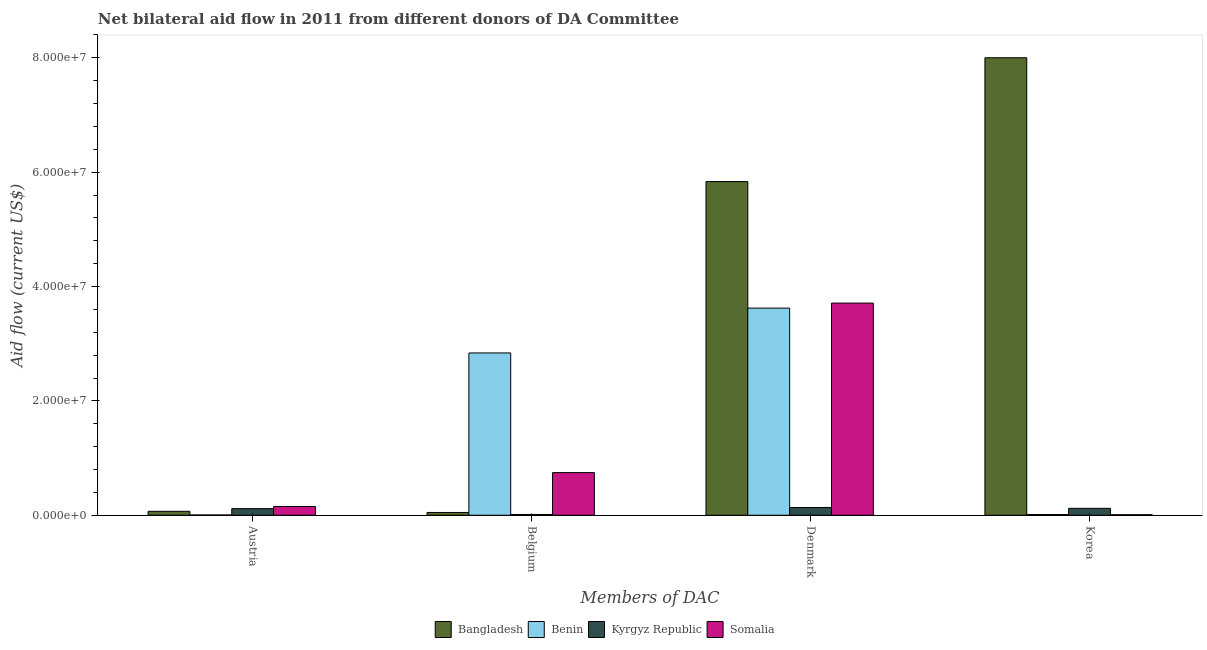How many different coloured bars are there?
Offer a very short reply. 4. How many groups of bars are there?
Ensure brevity in your answer.  4. Are the number of bars per tick equal to the number of legend labels?
Offer a very short reply. Yes. Are the number of bars on each tick of the X-axis equal?
Your answer should be compact. Yes. How many bars are there on the 1st tick from the left?
Your answer should be very brief. 4. How many bars are there on the 4th tick from the right?
Your answer should be very brief. 4. What is the label of the 2nd group of bars from the left?
Keep it short and to the point. Belgium. What is the amount of aid given by austria in Kyrgyz Republic?
Make the answer very short. 1.16e+06. Across all countries, what is the maximum amount of aid given by austria?
Keep it short and to the point. 1.54e+06. Across all countries, what is the minimum amount of aid given by austria?
Keep it short and to the point. 5.00e+04. In which country was the amount of aid given by belgium maximum?
Your answer should be very brief. Benin. In which country was the amount of aid given by belgium minimum?
Keep it short and to the point. Kyrgyz Republic. What is the total amount of aid given by belgium in the graph?
Make the answer very short. 3.65e+07. What is the difference between the amount of aid given by austria in Bangladesh and that in Benin?
Ensure brevity in your answer.  6.40e+05. What is the difference between the amount of aid given by belgium in Bangladesh and the amount of aid given by austria in Kyrgyz Republic?
Your response must be concise. -6.70e+05. What is the average amount of aid given by austria per country?
Your response must be concise. 8.60e+05. What is the difference between the amount of aid given by belgium and amount of aid given by denmark in Bangladesh?
Provide a short and direct response. -5.79e+07. In how many countries, is the amount of aid given by austria greater than 16000000 US$?
Your response must be concise. 0. What is the ratio of the amount of aid given by austria in Bangladesh to that in Kyrgyz Republic?
Offer a terse response. 0.59. Is the amount of aid given by belgium in Kyrgyz Republic less than that in Somalia?
Offer a very short reply. Yes. Is the difference between the amount of aid given by korea in Somalia and Bangladesh greater than the difference between the amount of aid given by belgium in Somalia and Bangladesh?
Ensure brevity in your answer.  No. What is the difference between the highest and the second highest amount of aid given by austria?
Ensure brevity in your answer.  3.80e+05. What is the difference between the highest and the lowest amount of aid given by denmark?
Make the answer very short. 5.70e+07. In how many countries, is the amount of aid given by austria greater than the average amount of aid given by austria taken over all countries?
Your answer should be compact. 2. Is the sum of the amount of aid given by belgium in Somalia and Benin greater than the maximum amount of aid given by austria across all countries?
Give a very brief answer. Yes. What does the 4th bar from the left in Denmark represents?
Your response must be concise. Somalia. What does the 3rd bar from the right in Korea represents?
Give a very brief answer. Benin. Is it the case that in every country, the sum of the amount of aid given by austria and amount of aid given by belgium is greater than the amount of aid given by denmark?
Your response must be concise. No. How many bars are there?
Your response must be concise. 16. Are all the bars in the graph horizontal?
Provide a short and direct response. No. What is the difference between two consecutive major ticks on the Y-axis?
Your answer should be very brief. 2.00e+07. How many legend labels are there?
Give a very brief answer. 4. What is the title of the graph?
Your answer should be compact. Net bilateral aid flow in 2011 from different donors of DA Committee. Does "Caribbean small states" appear as one of the legend labels in the graph?
Give a very brief answer. No. What is the label or title of the X-axis?
Offer a terse response. Members of DAC. What is the label or title of the Y-axis?
Make the answer very short. Aid flow (current US$). What is the Aid flow (current US$) in Bangladesh in Austria?
Ensure brevity in your answer.  6.90e+05. What is the Aid flow (current US$) in Kyrgyz Republic in Austria?
Ensure brevity in your answer.  1.16e+06. What is the Aid flow (current US$) in Somalia in Austria?
Your answer should be very brief. 1.54e+06. What is the Aid flow (current US$) in Benin in Belgium?
Offer a terse response. 2.84e+07. What is the Aid flow (current US$) in Somalia in Belgium?
Offer a very short reply. 7.46e+06. What is the Aid flow (current US$) in Bangladesh in Denmark?
Keep it short and to the point. 5.84e+07. What is the Aid flow (current US$) of Benin in Denmark?
Keep it short and to the point. 3.62e+07. What is the Aid flow (current US$) in Kyrgyz Republic in Denmark?
Your answer should be compact. 1.36e+06. What is the Aid flow (current US$) of Somalia in Denmark?
Make the answer very short. 3.71e+07. What is the Aid flow (current US$) in Bangladesh in Korea?
Offer a very short reply. 8.00e+07. What is the Aid flow (current US$) in Kyrgyz Republic in Korea?
Your response must be concise. 1.21e+06. Across all Members of DAC, what is the maximum Aid flow (current US$) in Bangladesh?
Your response must be concise. 8.00e+07. Across all Members of DAC, what is the maximum Aid flow (current US$) of Benin?
Your response must be concise. 3.62e+07. Across all Members of DAC, what is the maximum Aid flow (current US$) in Kyrgyz Republic?
Your answer should be very brief. 1.36e+06. Across all Members of DAC, what is the maximum Aid flow (current US$) of Somalia?
Offer a terse response. 3.71e+07. Across all Members of DAC, what is the minimum Aid flow (current US$) in Bangladesh?
Your answer should be compact. 4.90e+05. Across all Members of DAC, what is the minimum Aid flow (current US$) of Benin?
Ensure brevity in your answer.  5.00e+04. What is the total Aid flow (current US$) in Bangladesh in the graph?
Make the answer very short. 1.40e+08. What is the total Aid flow (current US$) of Benin in the graph?
Your answer should be very brief. 6.48e+07. What is the total Aid flow (current US$) of Kyrgyz Republic in the graph?
Provide a succinct answer. 3.87e+06. What is the total Aid flow (current US$) of Somalia in the graph?
Keep it short and to the point. 4.62e+07. What is the difference between the Aid flow (current US$) in Benin in Austria and that in Belgium?
Offer a very short reply. -2.83e+07. What is the difference between the Aid flow (current US$) in Kyrgyz Republic in Austria and that in Belgium?
Provide a short and direct response. 1.02e+06. What is the difference between the Aid flow (current US$) in Somalia in Austria and that in Belgium?
Your answer should be very brief. -5.92e+06. What is the difference between the Aid flow (current US$) in Bangladesh in Austria and that in Denmark?
Your response must be concise. -5.77e+07. What is the difference between the Aid flow (current US$) in Benin in Austria and that in Denmark?
Your answer should be very brief. -3.62e+07. What is the difference between the Aid flow (current US$) of Somalia in Austria and that in Denmark?
Offer a very short reply. -3.56e+07. What is the difference between the Aid flow (current US$) of Bangladesh in Austria and that in Korea?
Offer a very short reply. -7.93e+07. What is the difference between the Aid flow (current US$) in Kyrgyz Republic in Austria and that in Korea?
Offer a terse response. -5.00e+04. What is the difference between the Aid flow (current US$) of Somalia in Austria and that in Korea?
Keep it short and to the point. 1.44e+06. What is the difference between the Aid flow (current US$) of Bangladesh in Belgium and that in Denmark?
Your response must be concise. -5.79e+07. What is the difference between the Aid flow (current US$) of Benin in Belgium and that in Denmark?
Your answer should be very brief. -7.84e+06. What is the difference between the Aid flow (current US$) of Kyrgyz Republic in Belgium and that in Denmark?
Provide a short and direct response. -1.22e+06. What is the difference between the Aid flow (current US$) in Somalia in Belgium and that in Denmark?
Your answer should be compact. -2.96e+07. What is the difference between the Aid flow (current US$) in Bangladesh in Belgium and that in Korea?
Provide a short and direct response. -7.95e+07. What is the difference between the Aid flow (current US$) in Benin in Belgium and that in Korea?
Offer a terse response. 2.83e+07. What is the difference between the Aid flow (current US$) in Kyrgyz Republic in Belgium and that in Korea?
Your response must be concise. -1.07e+06. What is the difference between the Aid flow (current US$) of Somalia in Belgium and that in Korea?
Ensure brevity in your answer.  7.36e+06. What is the difference between the Aid flow (current US$) in Bangladesh in Denmark and that in Korea?
Offer a terse response. -2.17e+07. What is the difference between the Aid flow (current US$) in Benin in Denmark and that in Korea?
Ensure brevity in your answer.  3.61e+07. What is the difference between the Aid flow (current US$) in Kyrgyz Republic in Denmark and that in Korea?
Your answer should be compact. 1.50e+05. What is the difference between the Aid flow (current US$) in Somalia in Denmark and that in Korea?
Provide a short and direct response. 3.70e+07. What is the difference between the Aid flow (current US$) in Bangladesh in Austria and the Aid flow (current US$) in Benin in Belgium?
Your answer should be very brief. -2.77e+07. What is the difference between the Aid flow (current US$) in Bangladesh in Austria and the Aid flow (current US$) in Somalia in Belgium?
Your answer should be very brief. -6.77e+06. What is the difference between the Aid flow (current US$) of Benin in Austria and the Aid flow (current US$) of Kyrgyz Republic in Belgium?
Your answer should be very brief. -9.00e+04. What is the difference between the Aid flow (current US$) of Benin in Austria and the Aid flow (current US$) of Somalia in Belgium?
Keep it short and to the point. -7.41e+06. What is the difference between the Aid flow (current US$) of Kyrgyz Republic in Austria and the Aid flow (current US$) of Somalia in Belgium?
Keep it short and to the point. -6.30e+06. What is the difference between the Aid flow (current US$) of Bangladesh in Austria and the Aid flow (current US$) of Benin in Denmark?
Your answer should be very brief. -3.55e+07. What is the difference between the Aid flow (current US$) of Bangladesh in Austria and the Aid flow (current US$) of Kyrgyz Republic in Denmark?
Make the answer very short. -6.70e+05. What is the difference between the Aid flow (current US$) in Bangladesh in Austria and the Aid flow (current US$) in Somalia in Denmark?
Keep it short and to the point. -3.64e+07. What is the difference between the Aid flow (current US$) in Benin in Austria and the Aid flow (current US$) in Kyrgyz Republic in Denmark?
Provide a short and direct response. -1.31e+06. What is the difference between the Aid flow (current US$) of Benin in Austria and the Aid flow (current US$) of Somalia in Denmark?
Offer a terse response. -3.71e+07. What is the difference between the Aid flow (current US$) of Kyrgyz Republic in Austria and the Aid flow (current US$) of Somalia in Denmark?
Your response must be concise. -3.60e+07. What is the difference between the Aid flow (current US$) in Bangladesh in Austria and the Aid flow (current US$) in Benin in Korea?
Provide a succinct answer. 5.60e+05. What is the difference between the Aid flow (current US$) of Bangladesh in Austria and the Aid flow (current US$) of Kyrgyz Republic in Korea?
Provide a succinct answer. -5.20e+05. What is the difference between the Aid flow (current US$) of Bangladesh in Austria and the Aid flow (current US$) of Somalia in Korea?
Ensure brevity in your answer.  5.90e+05. What is the difference between the Aid flow (current US$) of Benin in Austria and the Aid flow (current US$) of Kyrgyz Republic in Korea?
Offer a terse response. -1.16e+06. What is the difference between the Aid flow (current US$) of Kyrgyz Republic in Austria and the Aid flow (current US$) of Somalia in Korea?
Provide a succinct answer. 1.06e+06. What is the difference between the Aid flow (current US$) of Bangladesh in Belgium and the Aid flow (current US$) of Benin in Denmark?
Offer a very short reply. -3.57e+07. What is the difference between the Aid flow (current US$) of Bangladesh in Belgium and the Aid flow (current US$) of Kyrgyz Republic in Denmark?
Keep it short and to the point. -8.70e+05. What is the difference between the Aid flow (current US$) of Bangladesh in Belgium and the Aid flow (current US$) of Somalia in Denmark?
Your answer should be compact. -3.66e+07. What is the difference between the Aid flow (current US$) in Benin in Belgium and the Aid flow (current US$) in Kyrgyz Republic in Denmark?
Ensure brevity in your answer.  2.70e+07. What is the difference between the Aid flow (current US$) in Benin in Belgium and the Aid flow (current US$) in Somalia in Denmark?
Keep it short and to the point. -8.72e+06. What is the difference between the Aid flow (current US$) in Kyrgyz Republic in Belgium and the Aid flow (current US$) in Somalia in Denmark?
Provide a succinct answer. -3.70e+07. What is the difference between the Aid flow (current US$) in Bangladesh in Belgium and the Aid flow (current US$) in Kyrgyz Republic in Korea?
Offer a very short reply. -7.20e+05. What is the difference between the Aid flow (current US$) of Bangladesh in Belgium and the Aid flow (current US$) of Somalia in Korea?
Provide a short and direct response. 3.90e+05. What is the difference between the Aid flow (current US$) of Benin in Belgium and the Aid flow (current US$) of Kyrgyz Republic in Korea?
Offer a terse response. 2.72e+07. What is the difference between the Aid flow (current US$) of Benin in Belgium and the Aid flow (current US$) of Somalia in Korea?
Your answer should be very brief. 2.83e+07. What is the difference between the Aid flow (current US$) of Kyrgyz Republic in Belgium and the Aid flow (current US$) of Somalia in Korea?
Provide a short and direct response. 4.00e+04. What is the difference between the Aid flow (current US$) of Bangladesh in Denmark and the Aid flow (current US$) of Benin in Korea?
Your answer should be compact. 5.82e+07. What is the difference between the Aid flow (current US$) in Bangladesh in Denmark and the Aid flow (current US$) in Kyrgyz Republic in Korea?
Your answer should be compact. 5.72e+07. What is the difference between the Aid flow (current US$) in Bangladesh in Denmark and the Aid flow (current US$) in Somalia in Korea?
Your answer should be compact. 5.83e+07. What is the difference between the Aid flow (current US$) in Benin in Denmark and the Aid flow (current US$) in Kyrgyz Republic in Korea?
Keep it short and to the point. 3.50e+07. What is the difference between the Aid flow (current US$) in Benin in Denmark and the Aid flow (current US$) in Somalia in Korea?
Provide a short and direct response. 3.61e+07. What is the difference between the Aid flow (current US$) of Kyrgyz Republic in Denmark and the Aid flow (current US$) of Somalia in Korea?
Give a very brief answer. 1.26e+06. What is the average Aid flow (current US$) in Bangladesh per Members of DAC?
Provide a short and direct response. 3.49e+07. What is the average Aid flow (current US$) of Benin per Members of DAC?
Your answer should be very brief. 1.62e+07. What is the average Aid flow (current US$) of Kyrgyz Republic per Members of DAC?
Give a very brief answer. 9.68e+05. What is the average Aid flow (current US$) in Somalia per Members of DAC?
Make the answer very short. 1.16e+07. What is the difference between the Aid flow (current US$) of Bangladesh and Aid flow (current US$) of Benin in Austria?
Ensure brevity in your answer.  6.40e+05. What is the difference between the Aid flow (current US$) in Bangladesh and Aid flow (current US$) in Kyrgyz Republic in Austria?
Provide a succinct answer. -4.70e+05. What is the difference between the Aid flow (current US$) in Bangladesh and Aid flow (current US$) in Somalia in Austria?
Your response must be concise. -8.50e+05. What is the difference between the Aid flow (current US$) of Benin and Aid flow (current US$) of Kyrgyz Republic in Austria?
Provide a short and direct response. -1.11e+06. What is the difference between the Aid flow (current US$) in Benin and Aid flow (current US$) in Somalia in Austria?
Provide a succinct answer. -1.49e+06. What is the difference between the Aid flow (current US$) of Kyrgyz Republic and Aid flow (current US$) of Somalia in Austria?
Your response must be concise. -3.80e+05. What is the difference between the Aid flow (current US$) in Bangladesh and Aid flow (current US$) in Benin in Belgium?
Your answer should be very brief. -2.79e+07. What is the difference between the Aid flow (current US$) in Bangladesh and Aid flow (current US$) in Kyrgyz Republic in Belgium?
Your response must be concise. 3.50e+05. What is the difference between the Aid flow (current US$) in Bangladesh and Aid flow (current US$) in Somalia in Belgium?
Offer a terse response. -6.97e+06. What is the difference between the Aid flow (current US$) in Benin and Aid flow (current US$) in Kyrgyz Republic in Belgium?
Provide a short and direct response. 2.82e+07. What is the difference between the Aid flow (current US$) in Benin and Aid flow (current US$) in Somalia in Belgium?
Your answer should be very brief. 2.09e+07. What is the difference between the Aid flow (current US$) in Kyrgyz Republic and Aid flow (current US$) in Somalia in Belgium?
Your response must be concise. -7.32e+06. What is the difference between the Aid flow (current US$) of Bangladesh and Aid flow (current US$) of Benin in Denmark?
Ensure brevity in your answer.  2.21e+07. What is the difference between the Aid flow (current US$) of Bangladesh and Aid flow (current US$) of Kyrgyz Republic in Denmark?
Your answer should be compact. 5.70e+07. What is the difference between the Aid flow (current US$) of Bangladesh and Aid flow (current US$) of Somalia in Denmark?
Keep it short and to the point. 2.12e+07. What is the difference between the Aid flow (current US$) in Benin and Aid flow (current US$) in Kyrgyz Republic in Denmark?
Offer a terse response. 3.49e+07. What is the difference between the Aid flow (current US$) of Benin and Aid flow (current US$) of Somalia in Denmark?
Your response must be concise. -8.80e+05. What is the difference between the Aid flow (current US$) of Kyrgyz Republic and Aid flow (current US$) of Somalia in Denmark?
Offer a very short reply. -3.58e+07. What is the difference between the Aid flow (current US$) of Bangladesh and Aid flow (current US$) of Benin in Korea?
Your response must be concise. 7.99e+07. What is the difference between the Aid flow (current US$) in Bangladesh and Aid flow (current US$) in Kyrgyz Republic in Korea?
Keep it short and to the point. 7.88e+07. What is the difference between the Aid flow (current US$) in Bangladesh and Aid flow (current US$) in Somalia in Korea?
Provide a succinct answer. 7.99e+07. What is the difference between the Aid flow (current US$) in Benin and Aid flow (current US$) in Kyrgyz Republic in Korea?
Provide a short and direct response. -1.08e+06. What is the difference between the Aid flow (current US$) in Kyrgyz Republic and Aid flow (current US$) in Somalia in Korea?
Ensure brevity in your answer.  1.11e+06. What is the ratio of the Aid flow (current US$) of Bangladesh in Austria to that in Belgium?
Provide a short and direct response. 1.41. What is the ratio of the Aid flow (current US$) in Benin in Austria to that in Belgium?
Offer a very short reply. 0. What is the ratio of the Aid flow (current US$) in Kyrgyz Republic in Austria to that in Belgium?
Offer a very short reply. 8.29. What is the ratio of the Aid flow (current US$) of Somalia in Austria to that in Belgium?
Give a very brief answer. 0.21. What is the ratio of the Aid flow (current US$) in Bangladesh in Austria to that in Denmark?
Provide a short and direct response. 0.01. What is the ratio of the Aid flow (current US$) in Benin in Austria to that in Denmark?
Offer a very short reply. 0. What is the ratio of the Aid flow (current US$) in Kyrgyz Republic in Austria to that in Denmark?
Your response must be concise. 0.85. What is the ratio of the Aid flow (current US$) in Somalia in Austria to that in Denmark?
Provide a short and direct response. 0.04. What is the ratio of the Aid flow (current US$) of Bangladesh in Austria to that in Korea?
Ensure brevity in your answer.  0.01. What is the ratio of the Aid flow (current US$) in Benin in Austria to that in Korea?
Make the answer very short. 0.38. What is the ratio of the Aid flow (current US$) in Kyrgyz Republic in Austria to that in Korea?
Keep it short and to the point. 0.96. What is the ratio of the Aid flow (current US$) of Somalia in Austria to that in Korea?
Your answer should be compact. 15.4. What is the ratio of the Aid flow (current US$) of Bangladesh in Belgium to that in Denmark?
Your answer should be compact. 0.01. What is the ratio of the Aid flow (current US$) of Benin in Belgium to that in Denmark?
Give a very brief answer. 0.78. What is the ratio of the Aid flow (current US$) in Kyrgyz Republic in Belgium to that in Denmark?
Your response must be concise. 0.1. What is the ratio of the Aid flow (current US$) in Somalia in Belgium to that in Denmark?
Provide a short and direct response. 0.2. What is the ratio of the Aid flow (current US$) in Bangladesh in Belgium to that in Korea?
Give a very brief answer. 0.01. What is the ratio of the Aid flow (current US$) in Benin in Belgium to that in Korea?
Provide a short and direct response. 218.38. What is the ratio of the Aid flow (current US$) of Kyrgyz Republic in Belgium to that in Korea?
Make the answer very short. 0.12. What is the ratio of the Aid flow (current US$) of Somalia in Belgium to that in Korea?
Give a very brief answer. 74.6. What is the ratio of the Aid flow (current US$) of Bangladesh in Denmark to that in Korea?
Offer a very short reply. 0.73. What is the ratio of the Aid flow (current US$) of Benin in Denmark to that in Korea?
Your answer should be very brief. 278.69. What is the ratio of the Aid flow (current US$) in Kyrgyz Republic in Denmark to that in Korea?
Provide a succinct answer. 1.12. What is the ratio of the Aid flow (current US$) in Somalia in Denmark to that in Korea?
Provide a short and direct response. 371.1. What is the difference between the highest and the second highest Aid flow (current US$) in Bangladesh?
Ensure brevity in your answer.  2.17e+07. What is the difference between the highest and the second highest Aid flow (current US$) of Benin?
Offer a very short reply. 7.84e+06. What is the difference between the highest and the second highest Aid flow (current US$) of Kyrgyz Republic?
Make the answer very short. 1.50e+05. What is the difference between the highest and the second highest Aid flow (current US$) in Somalia?
Make the answer very short. 2.96e+07. What is the difference between the highest and the lowest Aid flow (current US$) in Bangladesh?
Provide a short and direct response. 7.95e+07. What is the difference between the highest and the lowest Aid flow (current US$) of Benin?
Offer a very short reply. 3.62e+07. What is the difference between the highest and the lowest Aid flow (current US$) of Kyrgyz Republic?
Your response must be concise. 1.22e+06. What is the difference between the highest and the lowest Aid flow (current US$) in Somalia?
Offer a very short reply. 3.70e+07. 